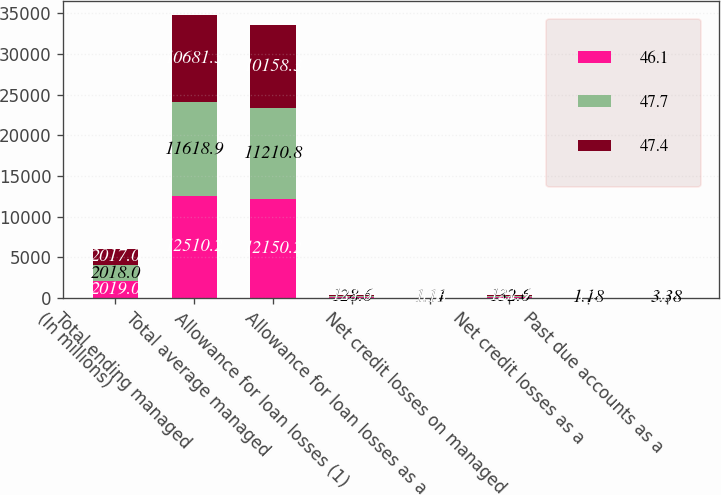<chart> <loc_0><loc_0><loc_500><loc_500><stacked_bar_chart><ecel><fcel>(In millions)<fcel>Total ending managed<fcel>Total average managed<fcel>Allowance for loan losses (1)<fcel>Allowance for loan losses as a<fcel>Net credit losses on managed<fcel>Net credit losses as a<fcel>Past due accounts as a<nl><fcel>46.1<fcel>2019<fcel>12510.2<fcel>12150.2<fcel>138.2<fcel>1.1<fcel>144.2<fcel>1.19<fcel>3.61<nl><fcel>47.7<fcel>2018<fcel>11618.9<fcel>11210.8<fcel>128.6<fcel>1.11<fcel>132.6<fcel>1.18<fcel>3.38<nl><fcel>47.4<fcel>2017<fcel>10681.3<fcel>10158.3<fcel>123.6<fcel>1.16<fcel>121.9<fcel>1.2<fcel>3.1<nl></chart> 